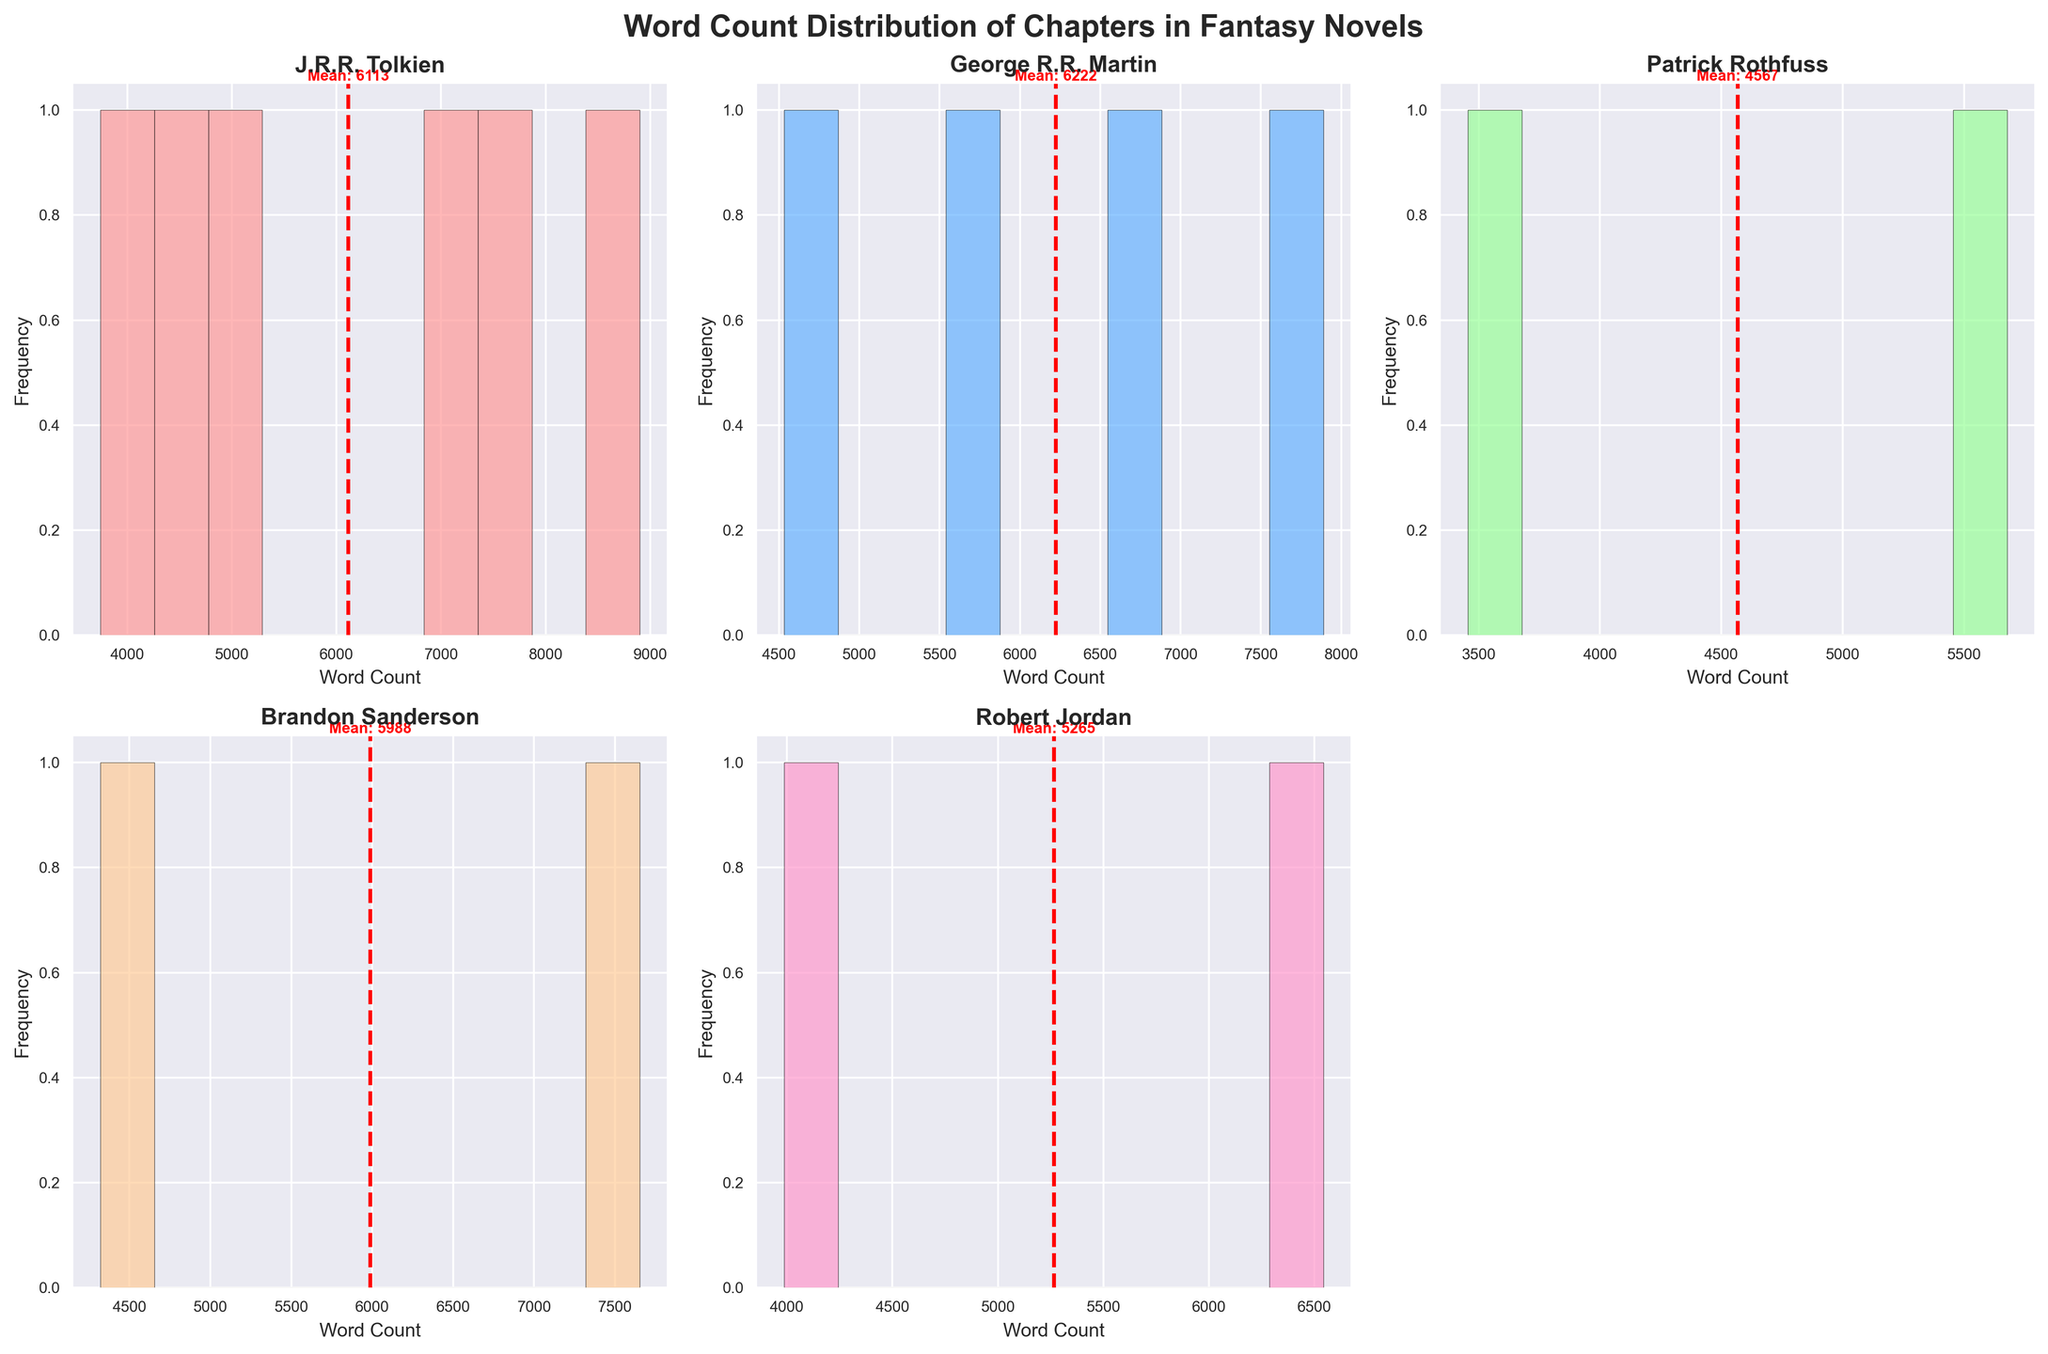What is the title of the plot? The plot has a title at the top of the figure which clearly mentions the scope of the visual representation. The title is "Word Count Distribution of Chapters in Fantasy Novels".
Answer: Word Count Distribution of Chapters in Fantasy Novels Which author has the highest mean word count for their chapters? In the subplots, the mean word count is indicated by a red dashed line with a label. By examining these lines, you can determine which author has the highest mean word count.
Answer: J.R.R. Tolkien What color is used for George R.R. Martin's histogram? Each author's histogram is shaded with a distinct color. Observing the subplot titled "George R.R. Martin," it's shaded in a specific color to differentiate it from others.
Answer: Light Blue What is the mean word count for Patrick Rothfuss's chapters? The mean word count for each author is marked by a red dashed line in the subplot. In Patrick Rothfuss's subplot, observe this line and the label next to it to find the mean word count.
Answer: 4567 Which author's data shows the widest range in word counts? Assessing the horizontal spread of each histogram's bars and considering the range suggested by the x-axis, identify the author whose histogram spans the widest range.
Answer: J.R.R. Tolkien How many subplots are there in total? The figure is organized into a grid of subplots. By counting all the subplots, including the one removed for balance, you can tally the total number.
Answer: 5 Which author has the most narrowly clustered word counts around the mean? By examining the histograms, look for the one with the least spread around the mean, indicated by the clustering of bars close to the red dashed line representing the mean.
Answer: Robert Jordan Are the x-axis labels the same for all subplots? Check the x-axes below each histogram to see if they all have the same label ("Word Count").
Answer: Yes Which subplot has the tallest bar? By comparing the height of the bars in each subplot visually, you can identify the subplot with the tallest bar representing the highest frequency for a word count range.
Answer: Brandon Sanderson How many histograms have a mean word count above 5000? By looking at each subplot and noting the mean word count marked by the red dashed line, count how many of these means are above 5000.
Answer: 3 